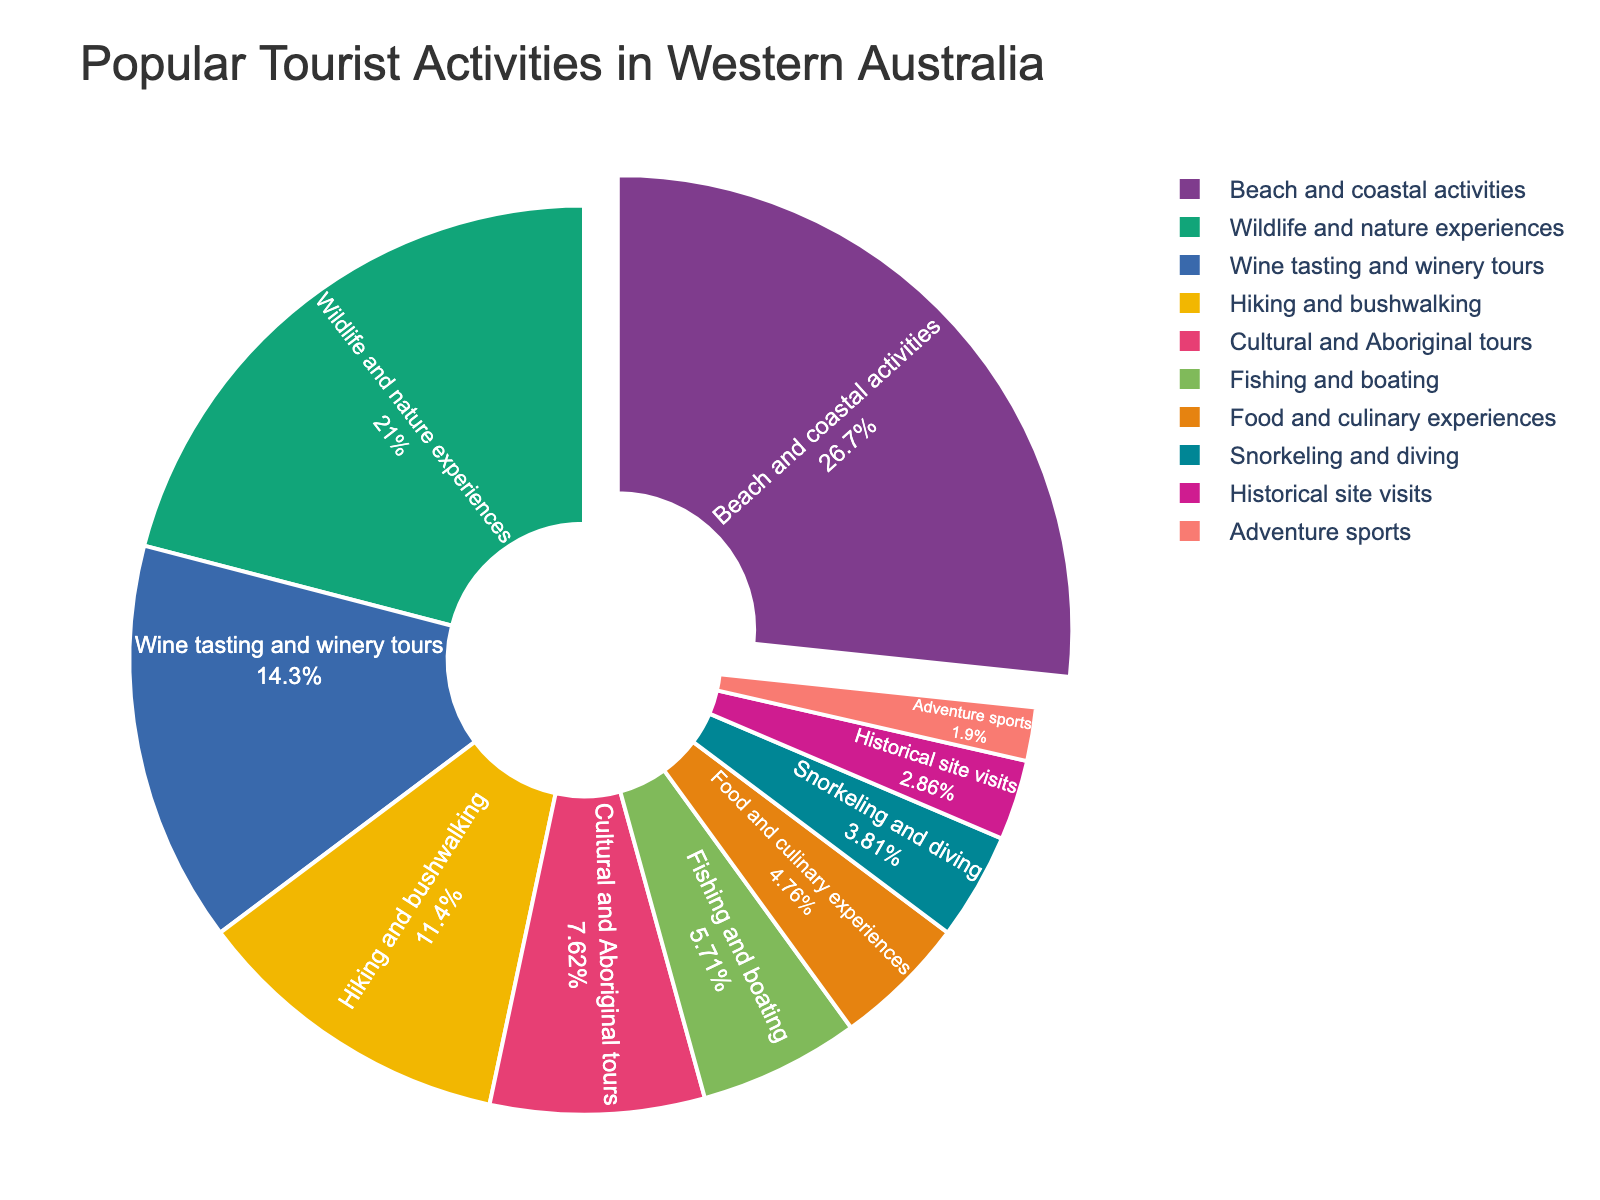Which activity has the highest percentage of participation among tourists in Western Australia? The figure shows a pie chart with segments for each activity. The size of the segment for "Beach and coastal activities" is the largest.
Answer: Beach and coastal activities Which two activities have the least popularity among tourists? The smallest segments in the pie chart represent "Historical site visits" and "Adventure sports."
Answer: Historical site visits and Adventure sports What is the combined percentage of tourists enjoying cultural and culinary experiences? The percentages for "Cultural and Aboriginal tours" and "Food and culinary experiences" are 8% and 5%. Sum these percentages: 8 + 5 = 13%.
Answer: 13% Is hiking and bushwalking more popular than wine tasting and winery tours among tourists? By comparing the segments, the percentage for "Hiking and bushwalking" is 12%, while "Wine tasting and winery tours" is 15%. Thus, hiking is less popular.
Answer: No What percentage of tourists prefer adventure sports over historical site visits? The segment for "Adventure sports" is 2%, and for "Historical site visits" is 3%. Subtract the percentage for adventure sports from historical site visits: 3 - 2 = 1%.
Answer: 1% What is the difference in popularity between the most and least favored activities? The most favored activity, "Beach and coastal activities," has 28%, and the least favored, "Adventure sports," has 2%. Subtract these percentages: 28 - 2 = 26%.
Answer: 26% Which activities constitute more than 20% of the total tourist activities? The segments for "Beach and coastal activities" (28%) and "Wildlife and nature experiences" (22%) are both greater than 20%.
Answer: Beach and coastal activities and Wildlife and nature experiences How many activities have a single-digit percentage share? The segments for "Cultural and Aboriginal tours," "Fishing and boating," "Food and culinary experiences," "Snorkeling and diving," "Historical site visits," and "Adventure sports" have percentages of 8%, 6%, 5%, 4%, 3%, and 2% respectively, which are all single-digit percentages. Counting these activities: 6 activities.
Answer: 6 activities 